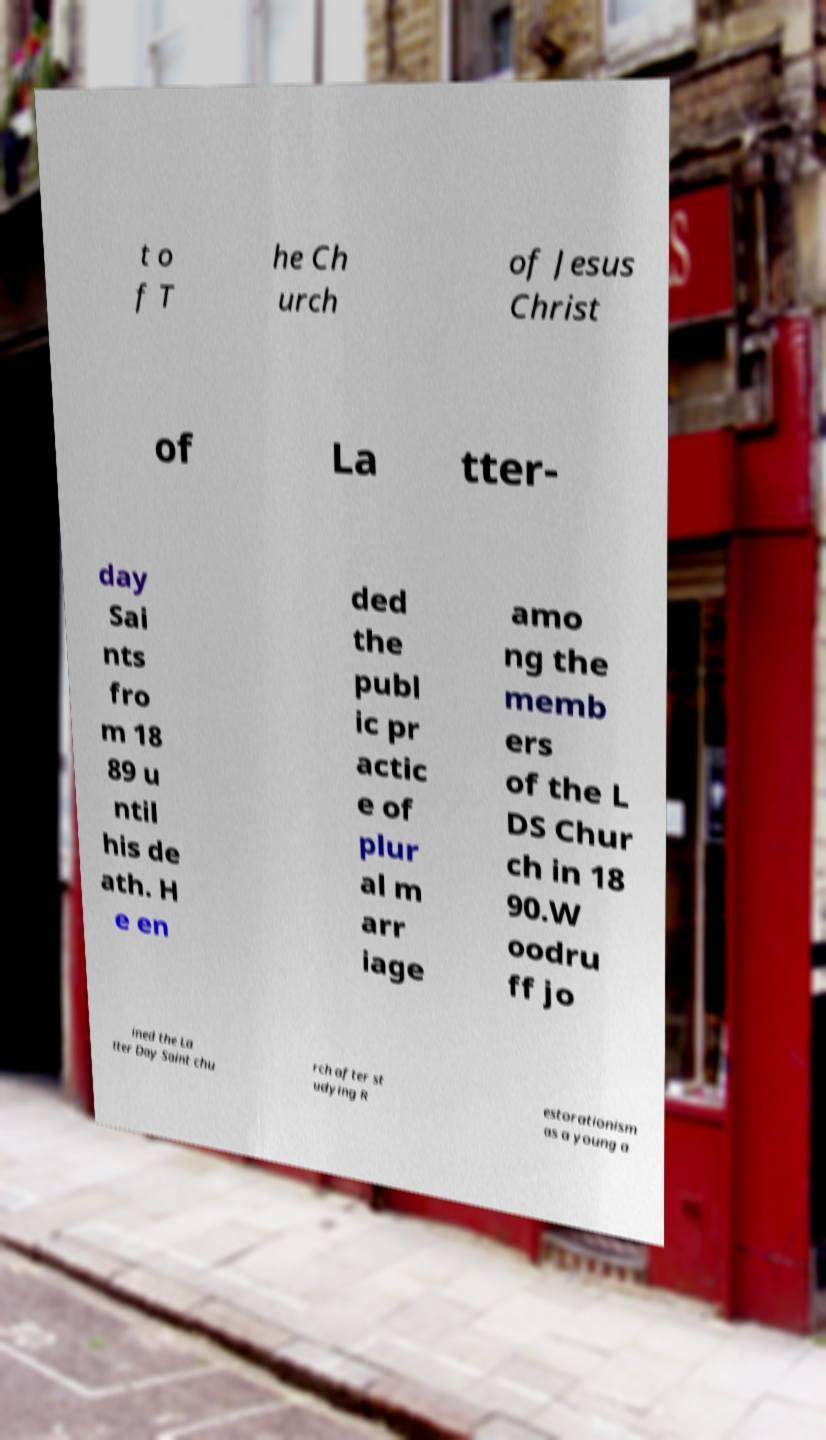For documentation purposes, I need the text within this image transcribed. Could you provide that? t o f T he Ch urch of Jesus Christ of La tter- day Sai nts fro m 18 89 u ntil his de ath. H e en ded the publ ic pr actic e of plur al m arr iage amo ng the memb ers of the L DS Chur ch in 18 90.W oodru ff jo ined the La tter Day Saint chu rch after st udying R estorationism as a young a 